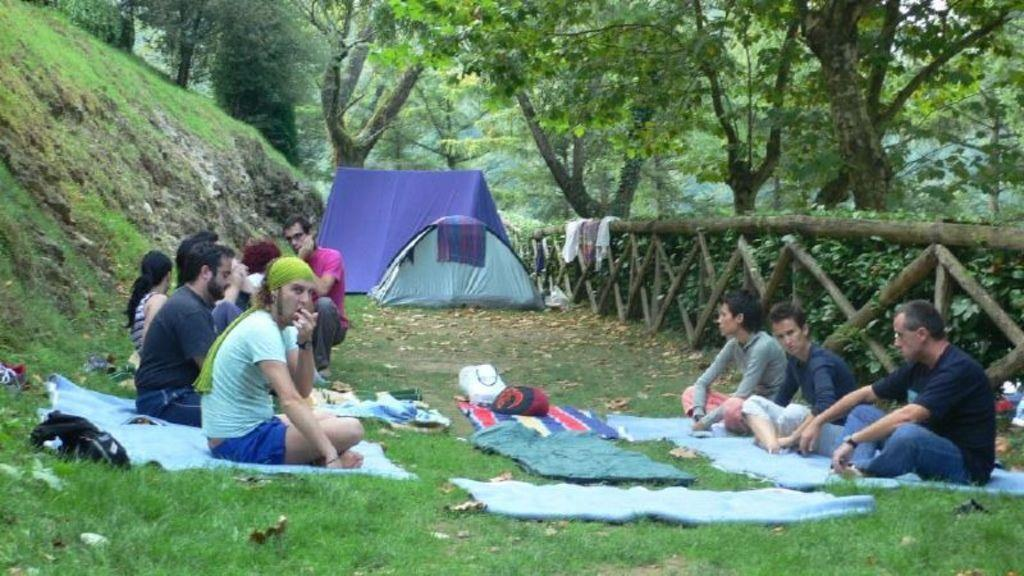What type of vegetation is present in the image? There is grass in the image. What items can be seen in addition to the grass? There are clothes, bags, and tents in the image. What are the persons in the image doing? The persons are sitting on the clothes. What type of structure is visible in the image? There are tents in the image. What architectural feature is present in the image? There is a fence in the image. What can be seen in the background of the image? There are trees in the background of the image. What type of gold form can be seen in the image? There is no gold form present in the image. 